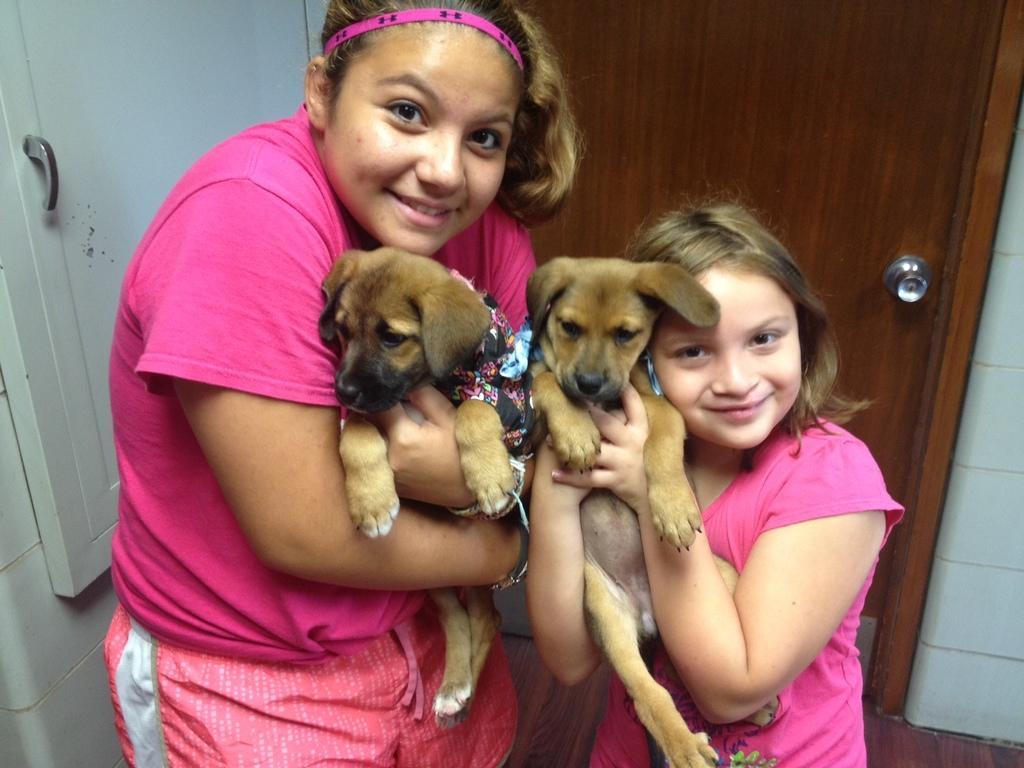Could you give a brief overview of what you see in this image? In this picture there are two persons, one woman in the left side and a kid in the right side. Both are wearing pink t shirts and both are holding two dogs. In the background there is a door with the handle. Towards the left there is a cupboard with a handle. 